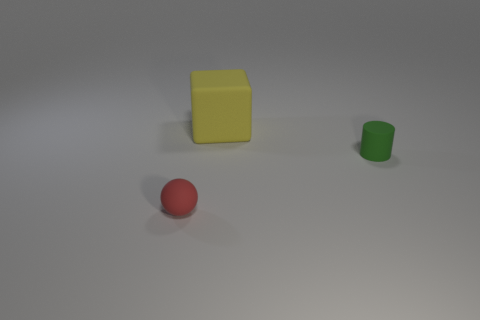What material is the small thing behind the small red thing to the left of the cube made of?
Ensure brevity in your answer.  Rubber. The other thing that is the same size as the red object is what shape?
Make the answer very short. Cylinder. Are there fewer tiny green matte cylinders than big brown metal blocks?
Keep it short and to the point. No. There is a object in front of the cylinder; is there a large matte cube left of it?
Your answer should be compact. No. There is a big yellow object that is made of the same material as the small green cylinder; what shape is it?
Your answer should be compact. Cube. Is there anything else of the same color as the sphere?
Provide a short and direct response. No. What number of other objects are the same size as the yellow object?
Your answer should be compact. 0. There is a small object behind the ball; does it have the same shape as the big matte object?
Ensure brevity in your answer.  No. What number of other things are the same shape as the yellow rubber object?
Make the answer very short. 0. The small rubber thing behind the matte ball has what shape?
Your answer should be very brief. Cylinder. 